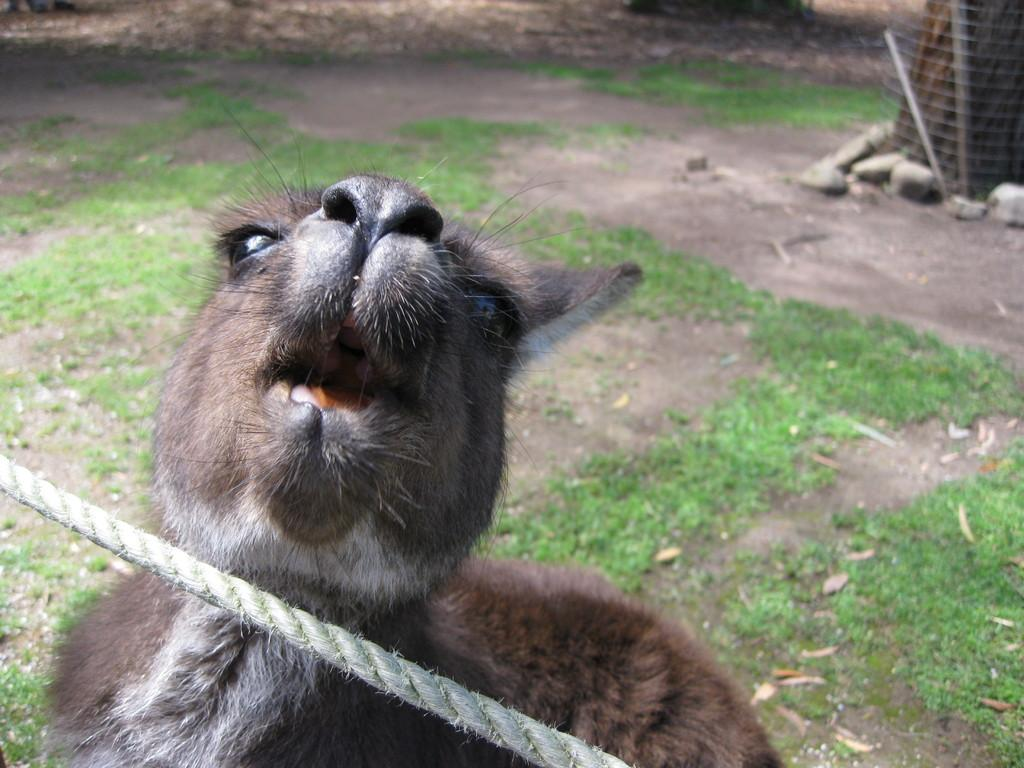What type of animal is in the image? The specific type of animal cannot be determined from the provided facts. What object is present in the image that can be used for tying or securing? There is a rope in the image that can be used for tying or securing. What is the terrain like in the image? The ground and grass are visible in the image, suggesting a grassy area. What is the purpose of the net in the image? The purpose of the net in the image cannot be determined from the provided facts. What material are the sticks in the image made of? The sticks in the image are made of wood. What type of objects are present in the image that can be used for throwing or hitting? The wooden sticks and stones in the image can be used for throwing or hitting. What type of vase can be seen in the image? There is no vase present in the image. Is the image set in a snowy environment? The provided facts do not mention any snow or snowy conditions, so it cannot be determined from the image. 